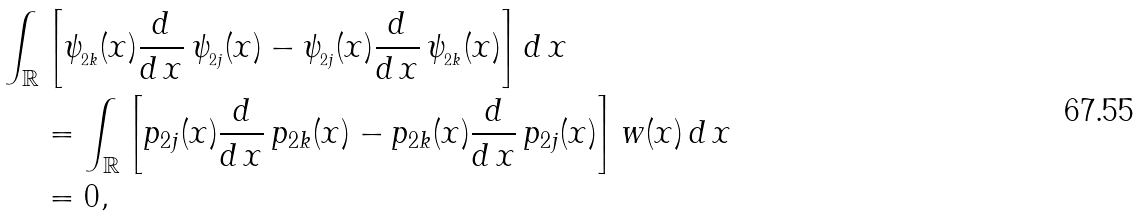<formula> <loc_0><loc_0><loc_500><loc_500>\int _ { \mathbb { R } } & \left [ \psi _ { _ { 2 k } } ( x ) \frac { d } { d \, x } \, \psi _ { _ { 2 j } } ( x ) - \psi _ { _ { 2 j } } ( x ) \frac { d } { d \, x } \, \psi _ { _ { 2 k } } ( x ) \right ] d \, x \\ & = \int _ { \mathbb { R } } \left [ p _ { 2 j } ( x ) \frac { d } { d \, x } \, p _ { 2 k } ( x ) - p _ { 2 k } ( x ) \frac { d } { d \, x } \, p _ { 2 j } ( x ) \right ] w ( x ) \, d \, x \\ & = 0 ,</formula> 